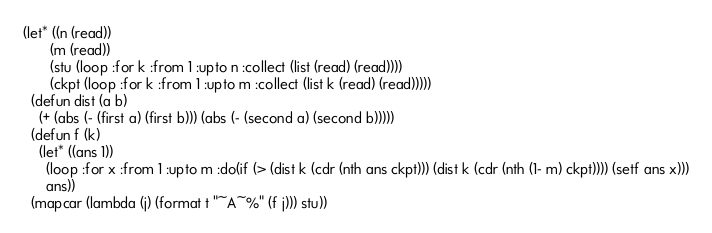<code> <loc_0><loc_0><loc_500><loc_500><_Lisp_>(let* ((n (read))
       (m (read))
       (stu (loop :for k :from 1 :upto n :collect (list (read) (read))))
       (ckpt (loop :for k :from 1 :upto m :collect (list k (read) (read)))))
  (defun dist (a b)
    (+ (abs (- (first a) (first b))) (abs (- (second a) (second b)))))
  (defun f (k)
    (let* ((ans 1))
      (loop :for x :from 1 :upto m :do(if (> (dist k (cdr (nth ans ckpt))) (dist k (cdr (nth (1- m) ckpt)))) (setf ans x)))
      ans))
  (mapcar (lambda (j) (format t "~A~%" (f j))) stu))</code> 